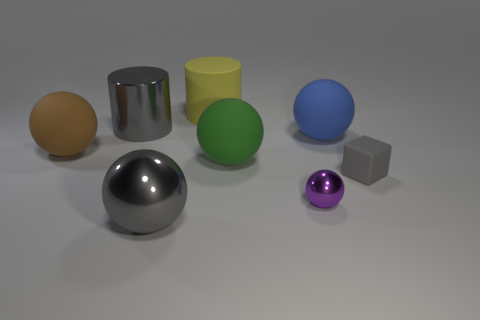What number of things are either large gray shiny things or large rubber objects that are behind the blue matte sphere?
Ensure brevity in your answer.  3. There is a rubber object that is in front of the brown rubber object and right of the tiny purple object; what color is it?
Offer a very short reply. Gray. Is the gray sphere the same size as the gray shiny cylinder?
Make the answer very short. Yes. What color is the big metal object that is in front of the large blue matte sphere?
Your answer should be very brief. Gray. Are there any tiny things that have the same color as the large shiny ball?
Your answer should be very brief. Yes. What color is the object that is the same size as the gray cube?
Your answer should be very brief. Purple. Do the big green thing and the tiny shiny thing have the same shape?
Make the answer very short. Yes. There is a yellow object behind the small block; what is its material?
Give a very brief answer. Rubber. The tiny sphere is what color?
Make the answer very short. Purple. Do the gray thing that is to the right of the tiny purple thing and the gray metallic cylinder that is left of the matte block have the same size?
Offer a very short reply. No. 